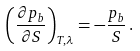<formula> <loc_0><loc_0><loc_500><loc_500>\left ( \frac { \partial p _ { b } } { \partial S } \right ) _ { T , \lambda } = - \frac { p _ { b } } { S } \, .</formula> 